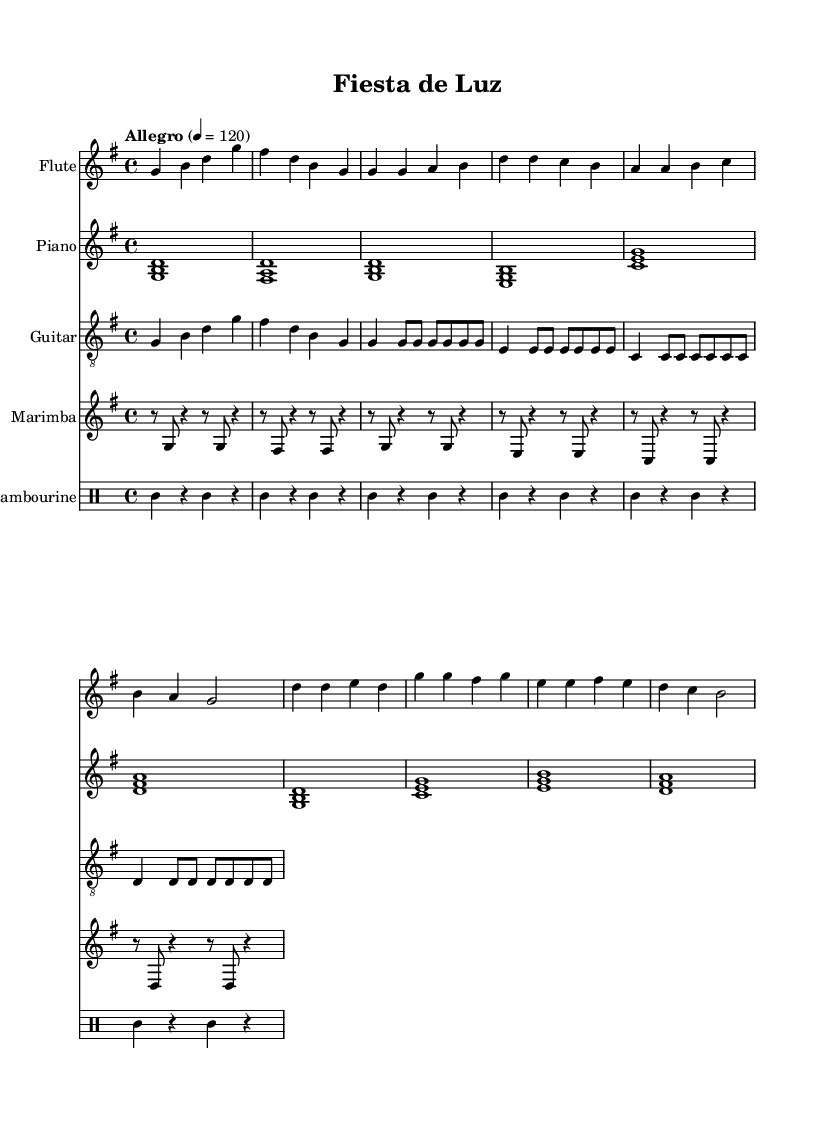What is the key signature of this music? The key signature indicated at the beginning shows one sharp, which corresponds to the key of G major.
Answer: G major What is the time signature of this composition? The time signature shown at the beginning of the score is 4/4, meaning there are four beats in a measure and the quarter note gets one beat.
Answer: 4/4 What is the tempo marking for this piece? The tempo marking is indicated as "Allegro," which suggests that the piece should be played at a fast, lively tempo. The metronome marking is 120 beats per minute.
Answer: Allegro How many instruments are featured in this composition? By counting the separate staves within the score, we see there are five distinct instruments included: Flute, Piano, Guitar, Marimba, and Tambourine.
Answer: Five What section does the time signature remain consistent throughout the piece? Since the time signature is established at the beginning as 4/4 and is not altered at any point in the music, it remains consistent throughout.
Answer: 4/4 What type of music does this composition represent? Given the title "Fiesta de Luz" and the instrumentation, which features elements commonly used in celebratory or festive themes, this composition represents a soundtrack for celebratory cultural themes.
Answer: Soundtrack 